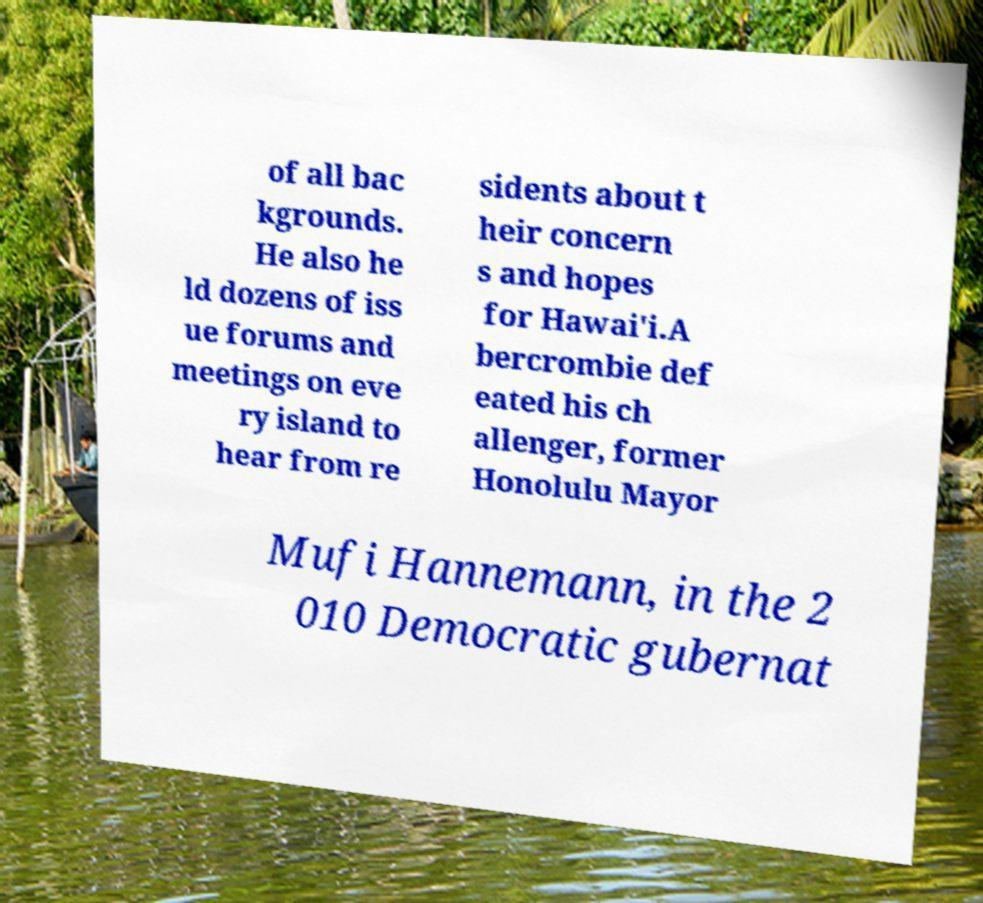What messages or text are displayed in this image? I need them in a readable, typed format. of all bac kgrounds. He also he ld dozens of iss ue forums and meetings on eve ry island to hear from re sidents about t heir concern s and hopes for Hawai'i.A bercrombie def eated his ch allenger, former Honolulu Mayor Mufi Hannemann, in the 2 010 Democratic gubernat 